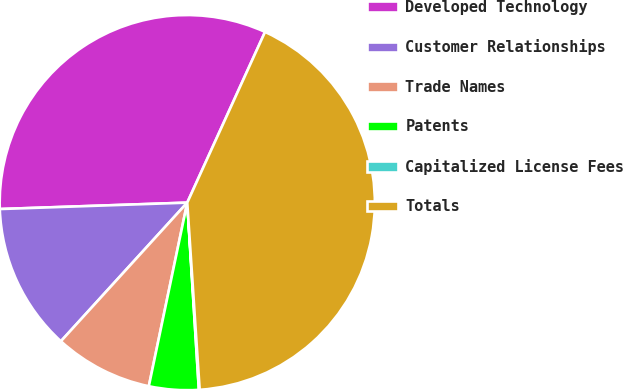Convert chart. <chart><loc_0><loc_0><loc_500><loc_500><pie_chart><fcel>Developed Technology<fcel>Customer Relationships<fcel>Trade Names<fcel>Patents<fcel>Capitalized License Fees<fcel>Totals<nl><fcel>32.35%<fcel>12.69%<fcel>8.48%<fcel>4.27%<fcel>0.07%<fcel>42.14%<nl></chart> 